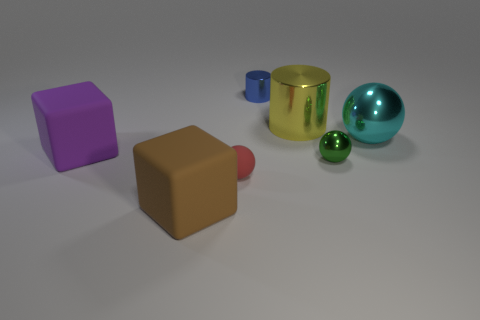Subtract all tiny spheres. How many spheres are left? 1 Add 2 large yellow metal objects. How many objects exist? 9 Subtract all green balls. How many balls are left? 2 Subtract all cubes. How many objects are left? 5 Subtract all brown spheres. Subtract all red cylinders. How many spheres are left? 3 Add 6 large spheres. How many large spheres are left? 7 Add 6 large yellow metallic spheres. How many large yellow metallic spheres exist? 6 Subtract 1 green spheres. How many objects are left? 6 Subtract all big yellow cylinders. Subtract all big cyan metallic objects. How many objects are left? 5 